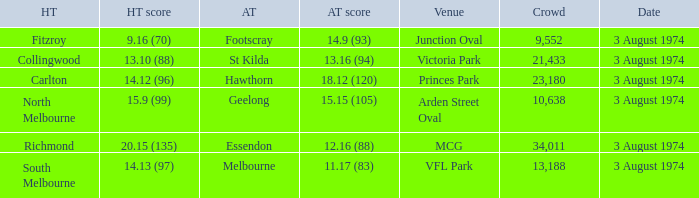Which Venue has a Home team score of 9.16 (70)? Junction Oval. 